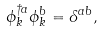<formula> <loc_0><loc_0><loc_500><loc_500>\phi ^ { \dag a } _ { k } \phi ^ { b } _ { k } = \delta ^ { a b } ,</formula> 